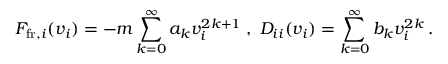<formula> <loc_0><loc_0><loc_500><loc_500>F _ { f r , i } ( v _ { i } ) = - m \sum _ { k = 0 } ^ { \infty } a _ { k } v _ { i } ^ { 2 k + 1 } \, , \, D _ { i i } ( v _ { i } ) = \sum _ { k = 0 } ^ { \infty } b _ { k } v _ { i } ^ { 2 k } \, .</formula> 